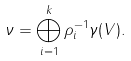<formula> <loc_0><loc_0><loc_500><loc_500>\nu = \bigoplus _ { i = 1 } ^ { k } \rho _ { i } ^ { - 1 } \gamma ( V ) .</formula> 